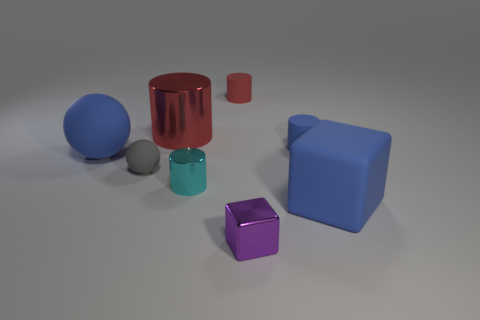Do the cyan metal thing and the large blue object left of the small cyan cylinder have the same shape?
Provide a short and direct response. No. Are there any other tiny things that have the same shape as the purple thing?
Your answer should be very brief. No. What shape is the red metal object that is on the right side of the large blue matte object behind the tiny cyan shiny thing?
Ensure brevity in your answer.  Cylinder. There is a object behind the red shiny cylinder; what shape is it?
Offer a very short reply. Cylinder. Do the large rubber thing on the right side of the tiny purple cube and the cylinder in front of the gray rubber thing have the same color?
Give a very brief answer. No. What number of blue rubber things are right of the blue rubber ball and behind the gray sphere?
Offer a terse response. 1. The other ball that is the same material as the gray ball is what size?
Your response must be concise. Large. What size is the cyan cylinder?
Ensure brevity in your answer.  Small. What is the large red cylinder made of?
Give a very brief answer. Metal. There is a blue matte thing left of the purple thing; is its size the same as the small ball?
Offer a very short reply. No. 